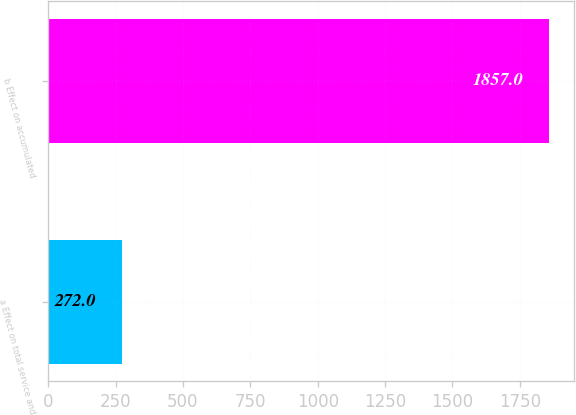Convert chart. <chart><loc_0><loc_0><loc_500><loc_500><bar_chart><fcel>a Effect on total service and<fcel>b Effect on accumulated<nl><fcel>272<fcel>1857<nl></chart> 